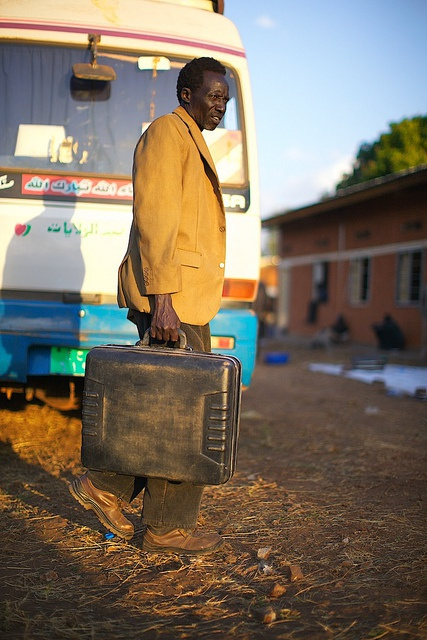Describe the objects in this image and their specific colors. I can see bus in tan, beige, darkgray, gray, and khaki tones, people in tan, orange, maroon, and black tones, suitcase in tan, gray, and black tones, people in black, maroon, and tan tones, and people in black and tan tones in this image. 